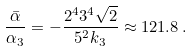Convert formula to latex. <formula><loc_0><loc_0><loc_500><loc_500>\frac { \bar { \alpha } } { \alpha _ { 3 } } = - \frac { 2 ^ { 4 } 3 ^ { 4 } \sqrt { 2 } } { 5 ^ { 2 } k _ { 3 } } \approx 1 2 1 . 8 \, .</formula> 